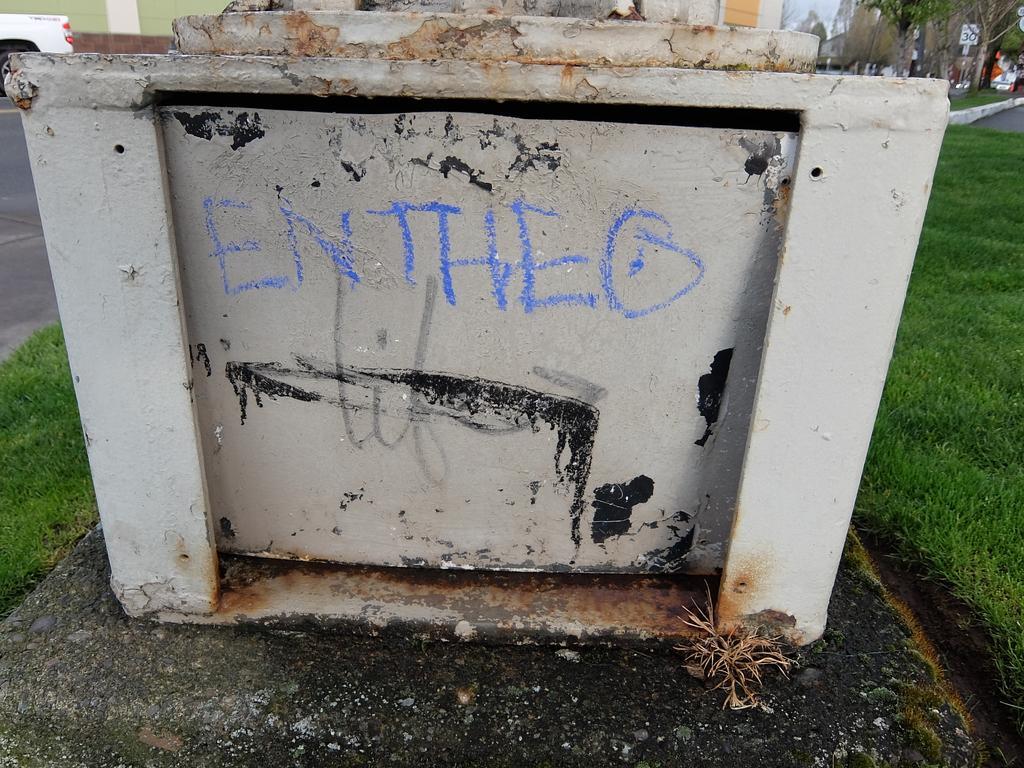How would you summarize this image in a sentence or two? Here in this picture we can see an iron frame, on which we can see some text written with a chalk piece over there and on the ground we can see grass covered all over there. 